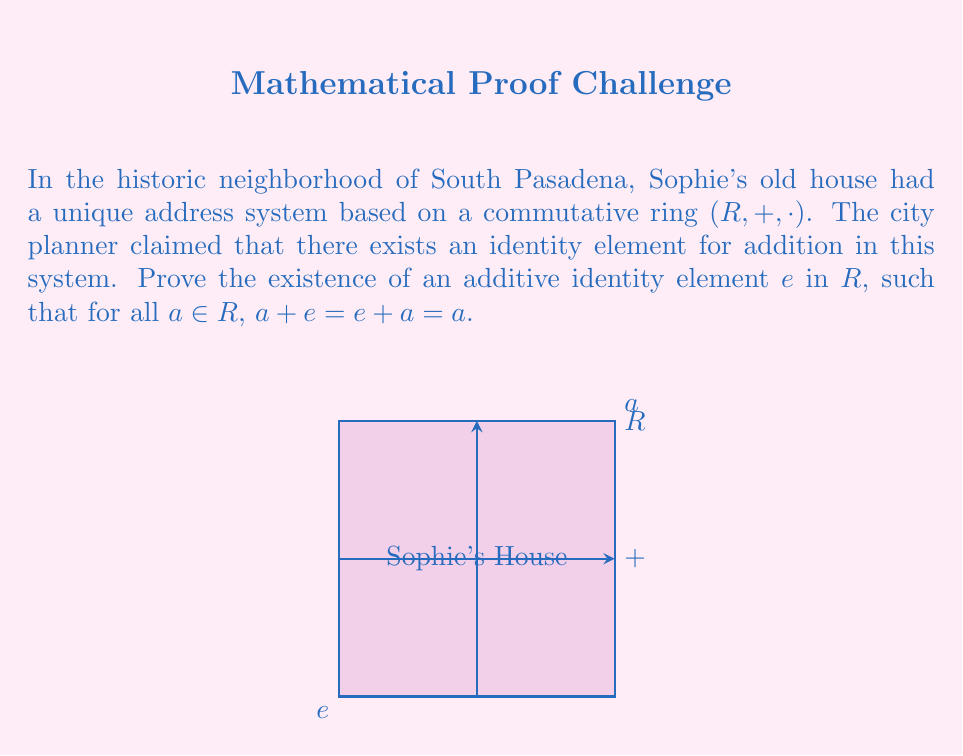Teach me how to tackle this problem. To prove the existence of an additive identity element in a commutative ring $(R, +, \cdot)$, we'll follow these steps:

1) Let $a$ be an arbitrary element in $R$.

2) Consider the element $a + a$. Since $R$ is closed under addition, $a + a \in R$.

3) Now, let's define an element $e = (a + a) - a$. This is well-defined because $R$ is a ring and thus has subtraction.

4) We claim that this $e$ is the additive identity. To prove this, we need to show that for any $x \in R$, $x + e = x$.

5) Let $x$ be an arbitrary element in $R$. Then:

   $x + e = x + ((a + a) - a)$

6) Using the associativity and commutativity of addition in $R$:

   $x + ((a + a) - a) = (x + (a + a)) - a = ((x + a) + a) - a$

7) Again, using associativity:

   $((x + a) + a) - a = (x + a) + (a - a) = x + (a + (a - a))$

8) Now, $a + (a - a) = a - (a - a) = (a - a) + a = 0 + a = a$

9) Therefore:

   $x + e = x + (a + (a - a)) = x + a = x$

10) Since $x$ was arbitrary, this holds for all elements in $R$.

11) By the commutativity of addition, we also have $e + x = x$ for all $x \in R$.

Thus, we have proven the existence of an additive identity element $e$ in the commutative ring $R$.
Answer: $e = (a + a) - a$ for any $a \in R$ 